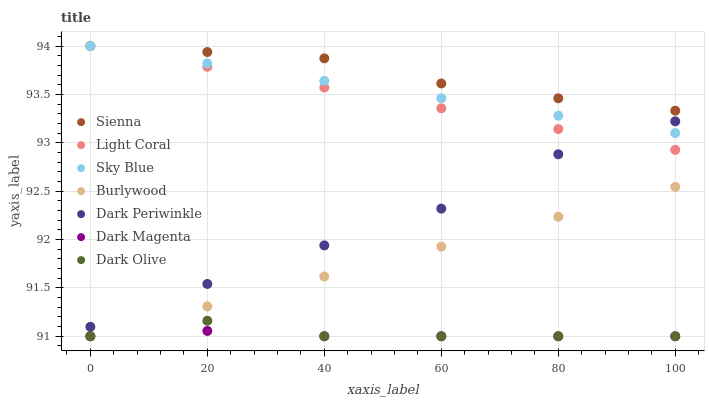Does Dark Magenta have the minimum area under the curve?
Answer yes or no. Yes. Does Sienna have the maximum area under the curve?
Answer yes or no. Yes. Does Burlywood have the minimum area under the curve?
Answer yes or no. No. Does Burlywood have the maximum area under the curve?
Answer yes or no. No. Is Light Coral the smoothest?
Answer yes or no. Yes. Is Dark Olive the roughest?
Answer yes or no. Yes. Is Dark Magenta the smoothest?
Answer yes or no. No. Is Dark Magenta the roughest?
Answer yes or no. No. Does Dark Magenta have the lowest value?
Answer yes or no. Yes. Does Sienna have the lowest value?
Answer yes or no. No. Does Sky Blue have the highest value?
Answer yes or no. Yes. Does Burlywood have the highest value?
Answer yes or no. No. Is Dark Olive less than Sienna?
Answer yes or no. Yes. Is Light Coral greater than Dark Magenta?
Answer yes or no. Yes. Does Sky Blue intersect Dark Periwinkle?
Answer yes or no. Yes. Is Sky Blue less than Dark Periwinkle?
Answer yes or no. No. Is Sky Blue greater than Dark Periwinkle?
Answer yes or no. No. Does Dark Olive intersect Sienna?
Answer yes or no. No. 